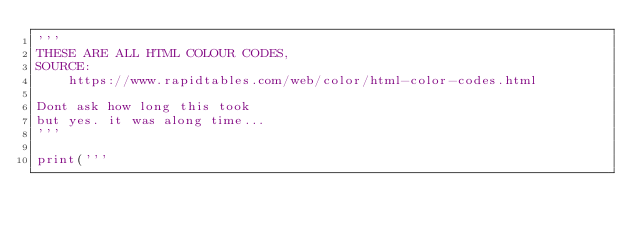Convert code to text. <code><loc_0><loc_0><loc_500><loc_500><_Python_>'''
THESE ARE ALL HTML COLOUR CODES,
SOURCE:
    https://www.rapidtables.com/web/color/html-color-codes.html
    
Dont ask how long this took
but yes. it was along time...
'''

print('''</code> 